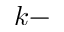Convert formula to latex. <formula><loc_0><loc_0><loc_500><loc_500>k -</formula> 